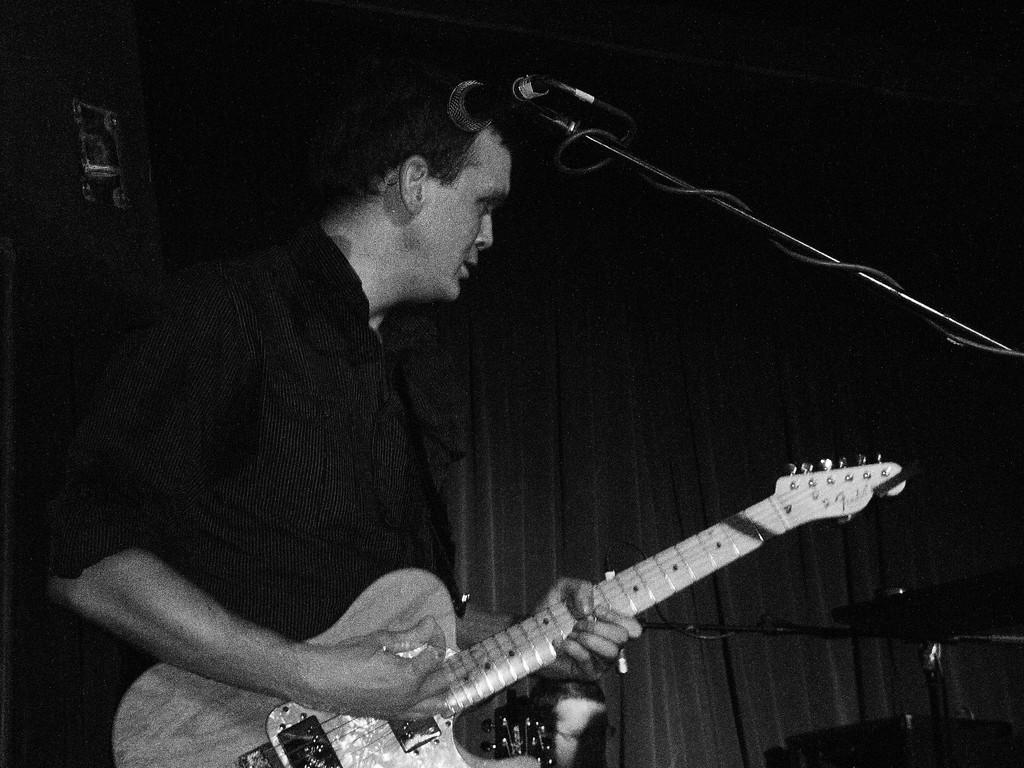Who is the main subject in the image? There is a man in the image. What is the man doing in the image? The man is playing a guitar. What equipment is present in the image for amplifying sound? There is a microphone and a microphone stand in the image. What can be seen in the background of the image? There is a curtain in the background of the image. How many dimes can be seen on the guitar in the image? There are no dimes visible on the guitar in the image. What page is the man reading from while playing the guitar? The man is not reading from a page while playing the guitar; he is focused on playing the instrument. 